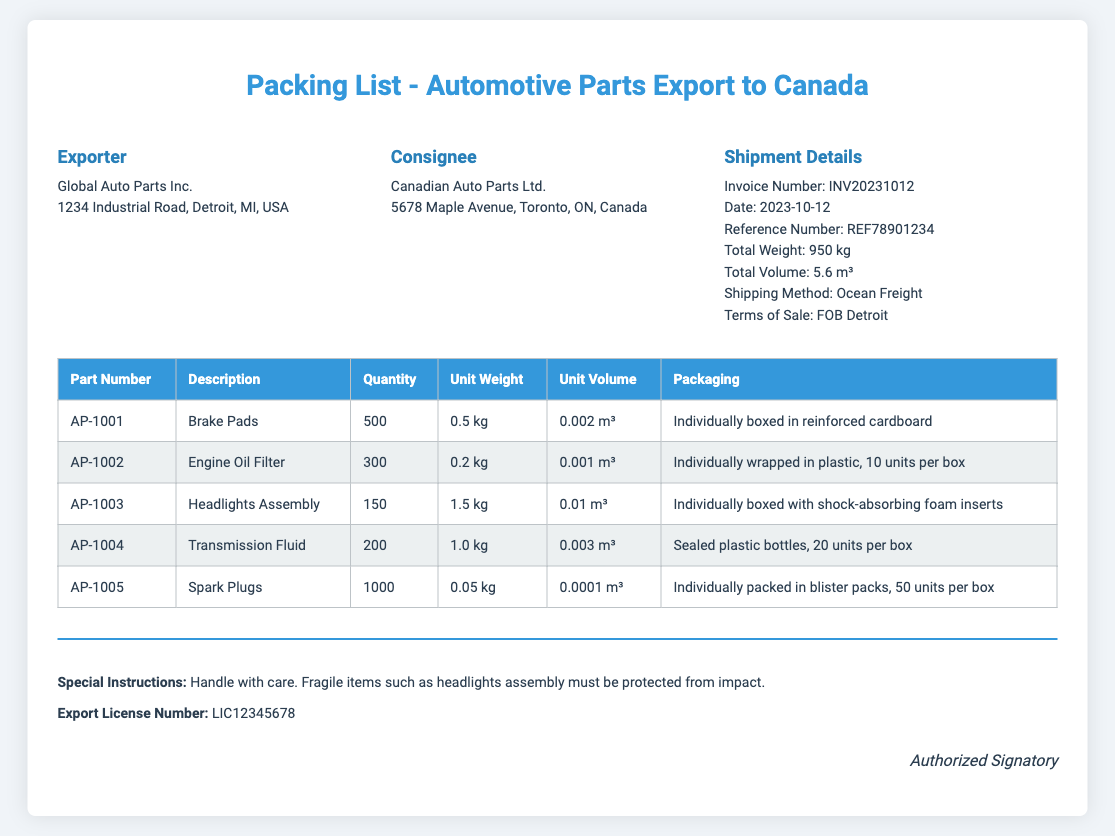What is the name of the exporter? The name of the exporter is stated in the header section.
Answer: Global Auto Parts Inc What is the total weight of the shipment? The total weight is specified in the shipment details section.
Answer: 950 kg How many engine oil filters are included? The quantity of engine oil filters is listed in the table for that specific part.
Answer: 300 What is the packaging requirement for the headlights assembly? The packaging requirement for the headlights assembly is described in the table under packaging.
Answer: Individually boxed with shock-absorbing foam inserts What is the invoice number? The invoice number is provided in the shipment details section.
Answer: INV20231012 How many spark plugs are included in each box? The packaging details for spark plugs mention this specific quantity.
Answer: 50 units per box What is the total volume of the shipment? The total volume is given in the shipment details section.
Answer: 5.6 m³ What special instruction is highlighted for the shipment? The special instructions are mentioned in the footer of the document.
Answer: Handle with care What is the unit weight of the brake pads? The unit weight of the brake pads is found in the table for that item.
Answer: 0.5 kg What is the export license number? The export license number is indicated in the footer section of the document.
Answer: LIC12345678 